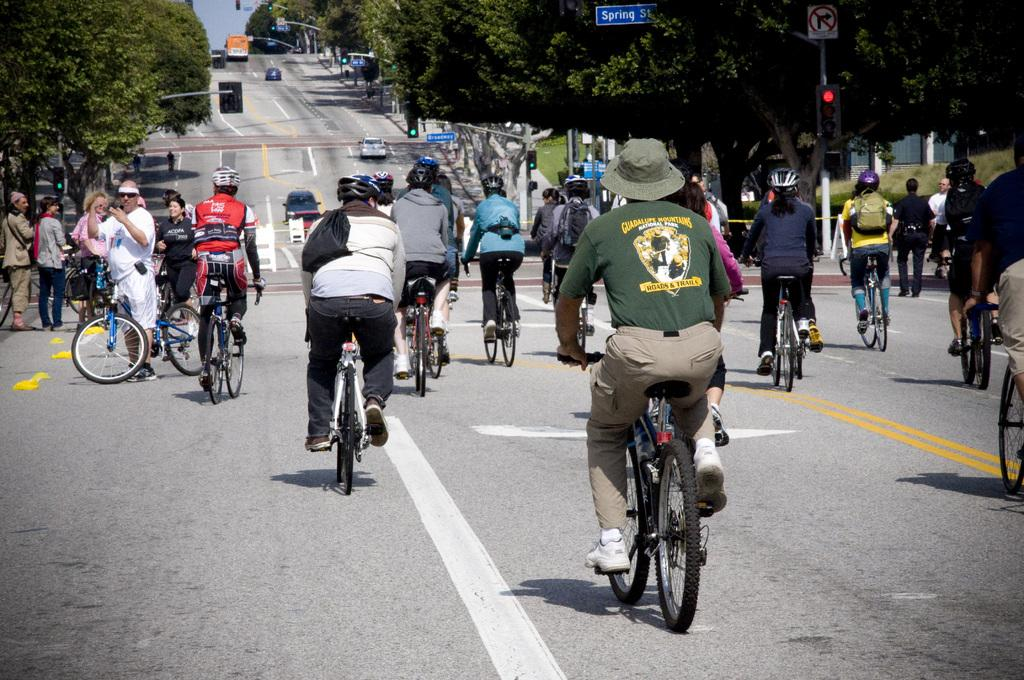What are the people in the image doing? The people in the image are riding bicycles. What else can be seen on the road in the image? There are vehicles on the road in the image. What type of natural elements are visible in the image? There are trees visible in the image. What helps regulate traffic in the image? There is a traffic signal in the image. What type of yoke can be seen being used by the people riding bicycles in the image? There is no yoke present in the image; the people are riding bicycles without any additional equipment. 